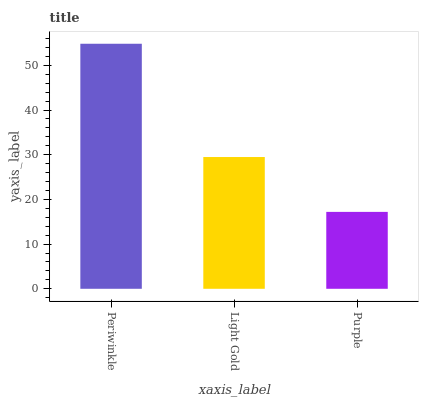Is Purple the minimum?
Answer yes or no. Yes. Is Periwinkle the maximum?
Answer yes or no. Yes. Is Light Gold the minimum?
Answer yes or no. No. Is Light Gold the maximum?
Answer yes or no. No. Is Periwinkle greater than Light Gold?
Answer yes or no. Yes. Is Light Gold less than Periwinkle?
Answer yes or no. Yes. Is Light Gold greater than Periwinkle?
Answer yes or no. No. Is Periwinkle less than Light Gold?
Answer yes or no. No. Is Light Gold the high median?
Answer yes or no. Yes. Is Light Gold the low median?
Answer yes or no. Yes. Is Purple the high median?
Answer yes or no. No. Is Periwinkle the low median?
Answer yes or no. No. 